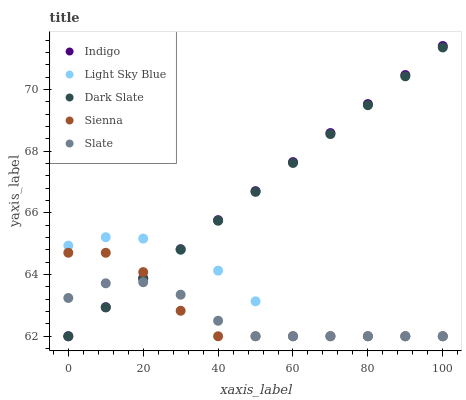Does Slate have the minimum area under the curve?
Answer yes or no. Yes. Does Indigo have the maximum area under the curve?
Answer yes or no. Yes. Does Dark Slate have the minimum area under the curve?
Answer yes or no. No. Does Dark Slate have the maximum area under the curve?
Answer yes or no. No. Is Dark Slate the smoothest?
Answer yes or no. Yes. Is Light Sky Blue the roughest?
Answer yes or no. Yes. Is Slate the smoothest?
Answer yes or no. No. Is Slate the roughest?
Answer yes or no. No. Does Sienna have the lowest value?
Answer yes or no. Yes. Does Indigo have the highest value?
Answer yes or no. Yes. Does Dark Slate have the highest value?
Answer yes or no. No. Does Light Sky Blue intersect Sienna?
Answer yes or no. Yes. Is Light Sky Blue less than Sienna?
Answer yes or no. No. Is Light Sky Blue greater than Sienna?
Answer yes or no. No. 